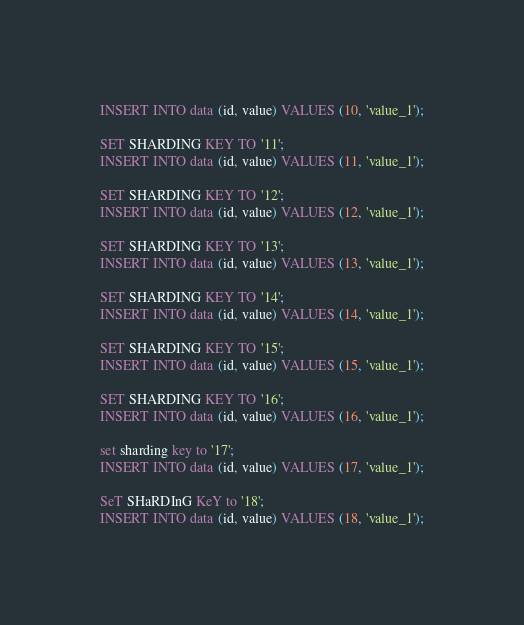Convert code to text. <code><loc_0><loc_0><loc_500><loc_500><_SQL_>INSERT INTO data (id, value) VALUES (10, 'value_1');

SET SHARDING KEY TO '11';
INSERT INTO data (id, value) VALUES (11, 'value_1');

SET SHARDING KEY TO '12';
INSERT INTO data (id, value) VALUES (12, 'value_1');

SET SHARDING KEY TO '13';
INSERT INTO data (id, value) VALUES (13, 'value_1');

SET SHARDING KEY TO '14';
INSERT INTO data (id, value) VALUES (14, 'value_1');

SET SHARDING KEY TO '15';
INSERT INTO data (id, value) VALUES (15, 'value_1');

SET SHARDING KEY TO '16';
INSERT INTO data (id, value) VALUES (16, 'value_1');

set sharding key to '17';
INSERT INTO data (id, value) VALUES (17, 'value_1');

SeT SHaRDInG KeY to '18';
INSERT INTO data (id, value) VALUES (18, 'value_1');
</code> 